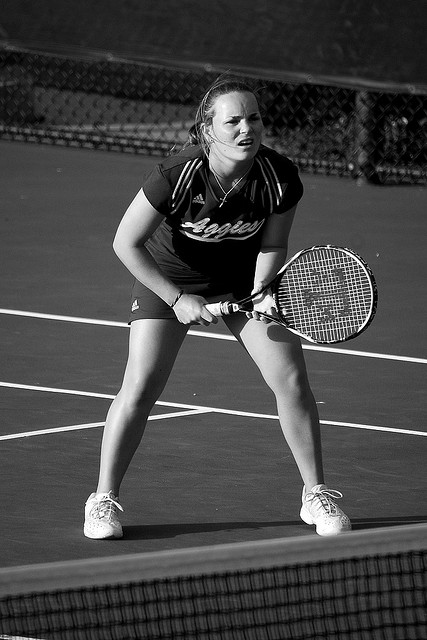Please transcribe the text in this image. Aggeesy 